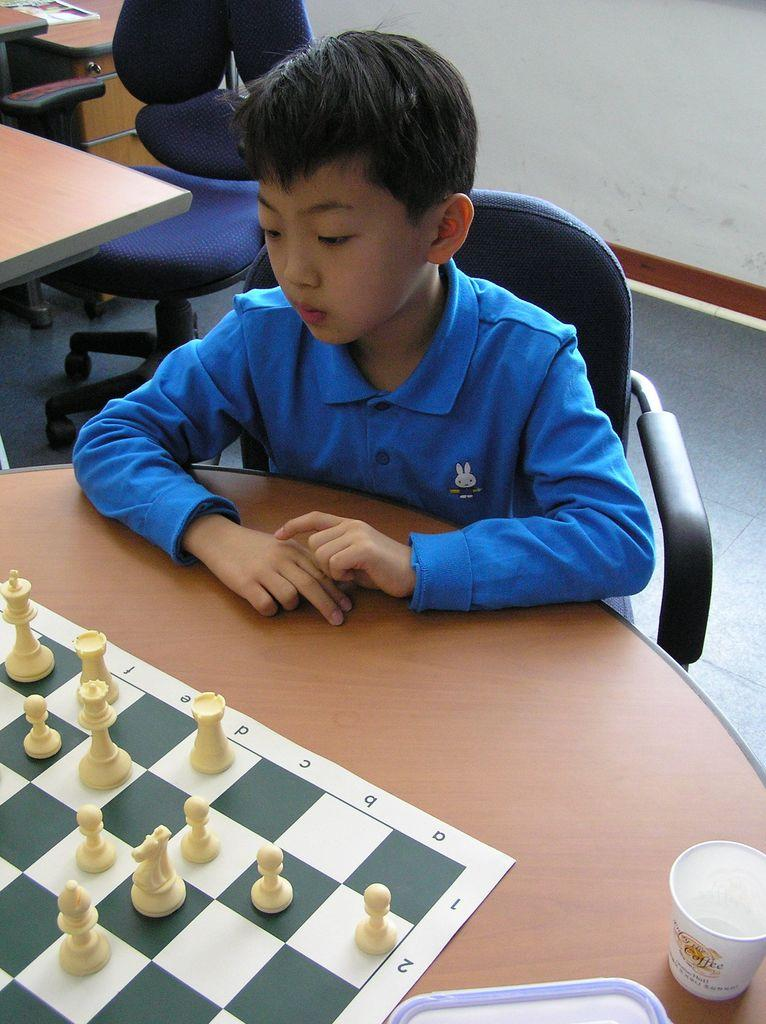What is the main subject of the image? The main subject of the image is a kid. What is the kid wearing in the image? The kid is wearing a blue t-shirt. What is the kid doing in the image? The kid is sitting on a chair. What can be seen on the right side of the image? There is a cup on the right side of the image. What type of rock is the kid holding in the image? There is no rock present in the image; the kid is wearing a blue t-shirt and sitting on a chair. 